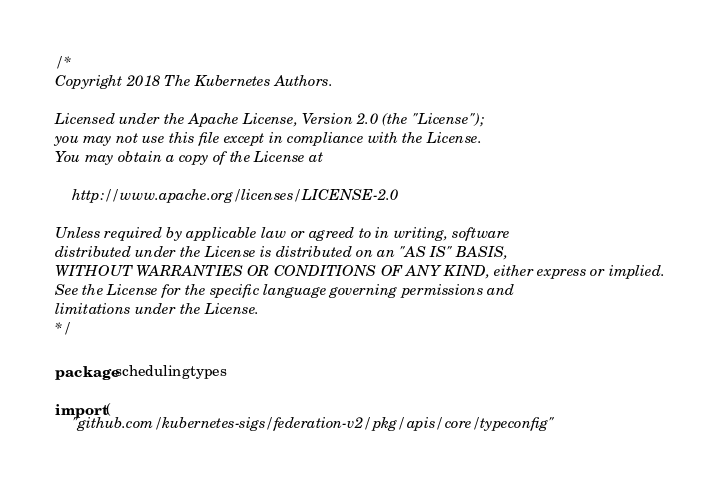<code> <loc_0><loc_0><loc_500><loc_500><_Go_>/*
Copyright 2018 The Kubernetes Authors.

Licensed under the Apache License, Version 2.0 (the "License");
you may not use this file except in compliance with the License.
You may obtain a copy of the License at

    http://www.apache.org/licenses/LICENSE-2.0

Unless required by applicable law or agreed to in writing, software
distributed under the License is distributed on an "AS IS" BASIS,
WITHOUT WARRANTIES OR CONDITIONS OF ANY KIND, either express or implied.
See the License for the specific language governing permissions and
limitations under the License.
*/

package schedulingtypes

import (
	"github.com/kubernetes-sigs/federation-v2/pkg/apis/core/typeconfig"</code> 